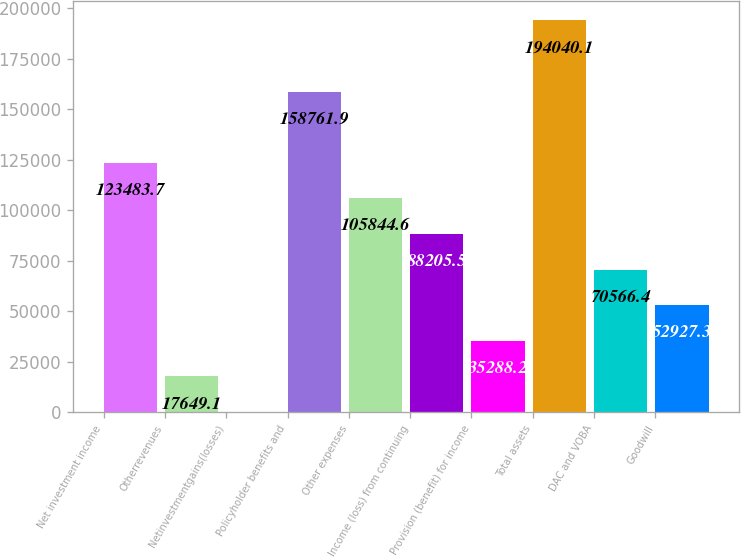Convert chart to OTSL. <chart><loc_0><loc_0><loc_500><loc_500><bar_chart><fcel>Net investment income<fcel>Otherrevenues<fcel>Netinvestmentgains(losses)<fcel>Policyholder benefits and<fcel>Other expenses<fcel>Income (loss) from continuing<fcel>Provision (benefit) for income<fcel>Total assets<fcel>DAC and VOBA<fcel>Goodwill<nl><fcel>123484<fcel>17649.1<fcel>10<fcel>158762<fcel>105845<fcel>88205.5<fcel>35288.2<fcel>194040<fcel>70566.4<fcel>52927.3<nl></chart> 